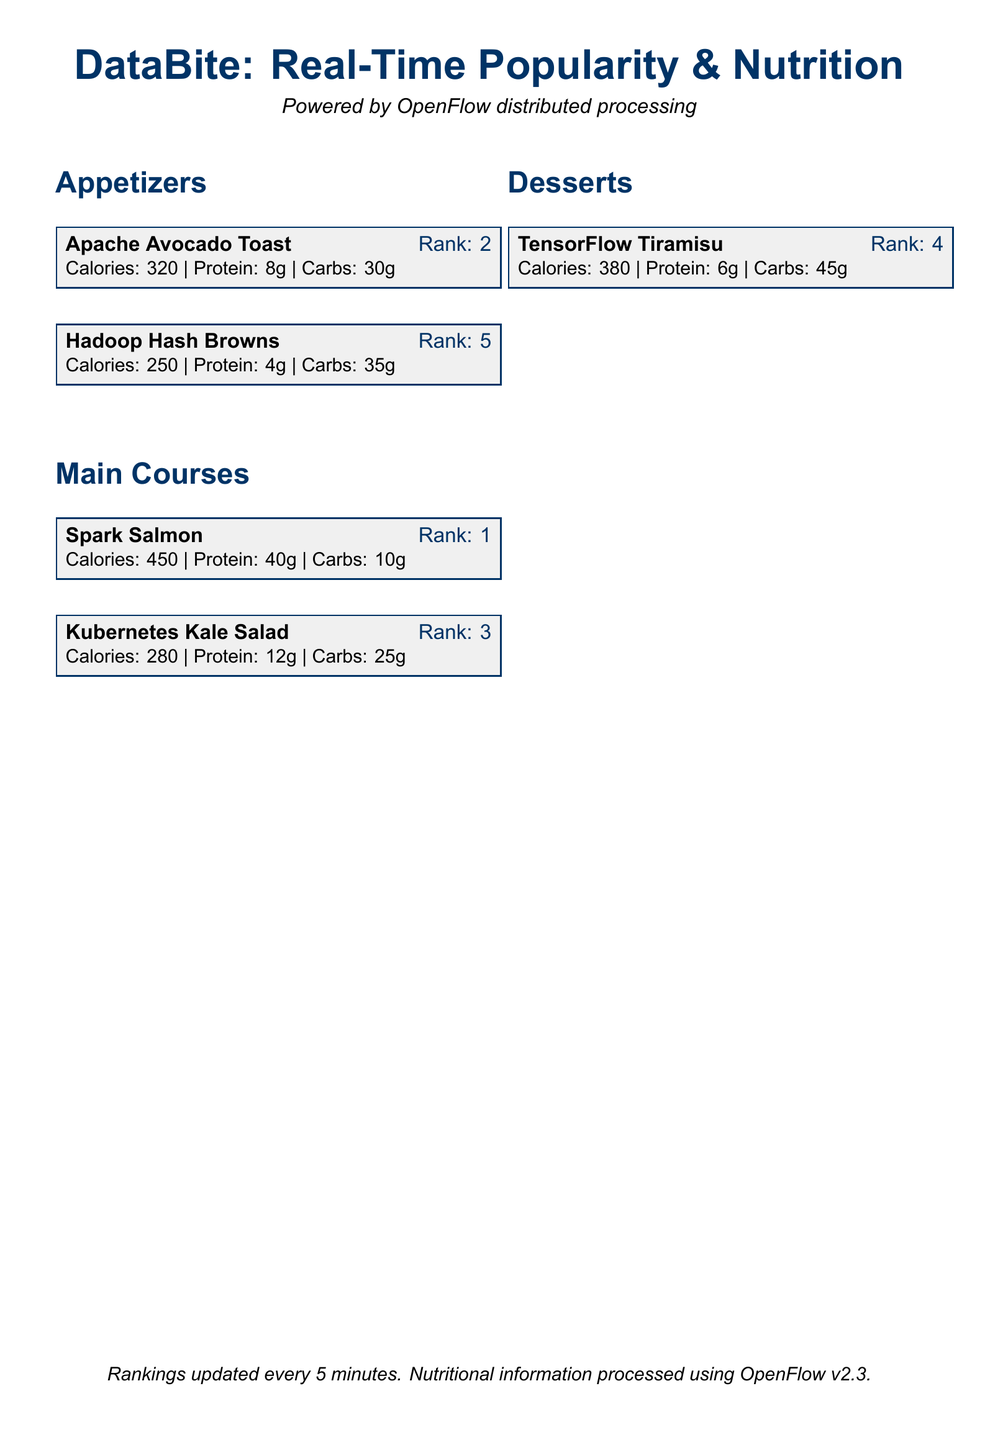What is the most popular appetizer? The most popular appetizer is the one with Rank 1, which is Spark Salmon.
Answer: Spark Salmon How many calories does the Kubernetes Kale Salad have? The nutritional information states that the Kubernetes Kale Salad has 280 calories.
Answer: 280 What dessert has the lowest protein content? The dessert with the lowest protein content is the one with the least grams of protein, which is TensorFlow Tiramisu with 6g.
Answer: TensorFlow Tiramisu What is the protein content of Apache Avocado Toast? The nutritional information lists the protein content of Apache Avocado Toast as 8g.
Answer: 8 Which main course has the highest rank? The main course with the highest rank is the one that is ranked 1, which is Spark Salmon.
Answer: Spark Salmon How often are the rankings updated? The document states that rankings are updated every 5 minutes.
Answer: every 5 minutes What is the total number of appetizers listed? The document lists two appetizers in the appetizers section.
Answer: 2 Which item has the highest calorie count in the Main Courses? The item with the highest calorie count is Spark Salmon with 450 calories.
Answer: Spark Salmon In which section is the Hadoop Hash Browns? The document states that Hadoop Hash Browns are listed under the Appetizers section.
Answer: Appetizers 